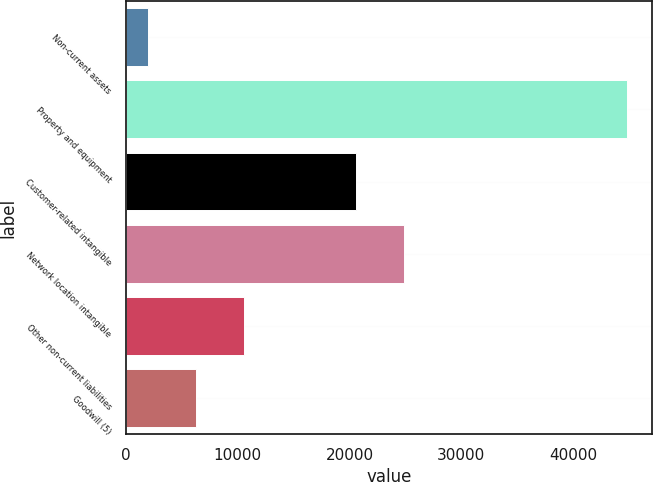Convert chart. <chart><loc_0><loc_0><loc_500><loc_500><bar_chart><fcel>Non-current assets<fcel>Property and equipment<fcel>Customer-related intangible<fcel>Network location intangible<fcel>Other non-current liabilities<fcel>Goodwill (5)<nl><fcel>1991<fcel>44844<fcel>20590<fcel>24875.3<fcel>10561.6<fcel>6276.3<nl></chart> 